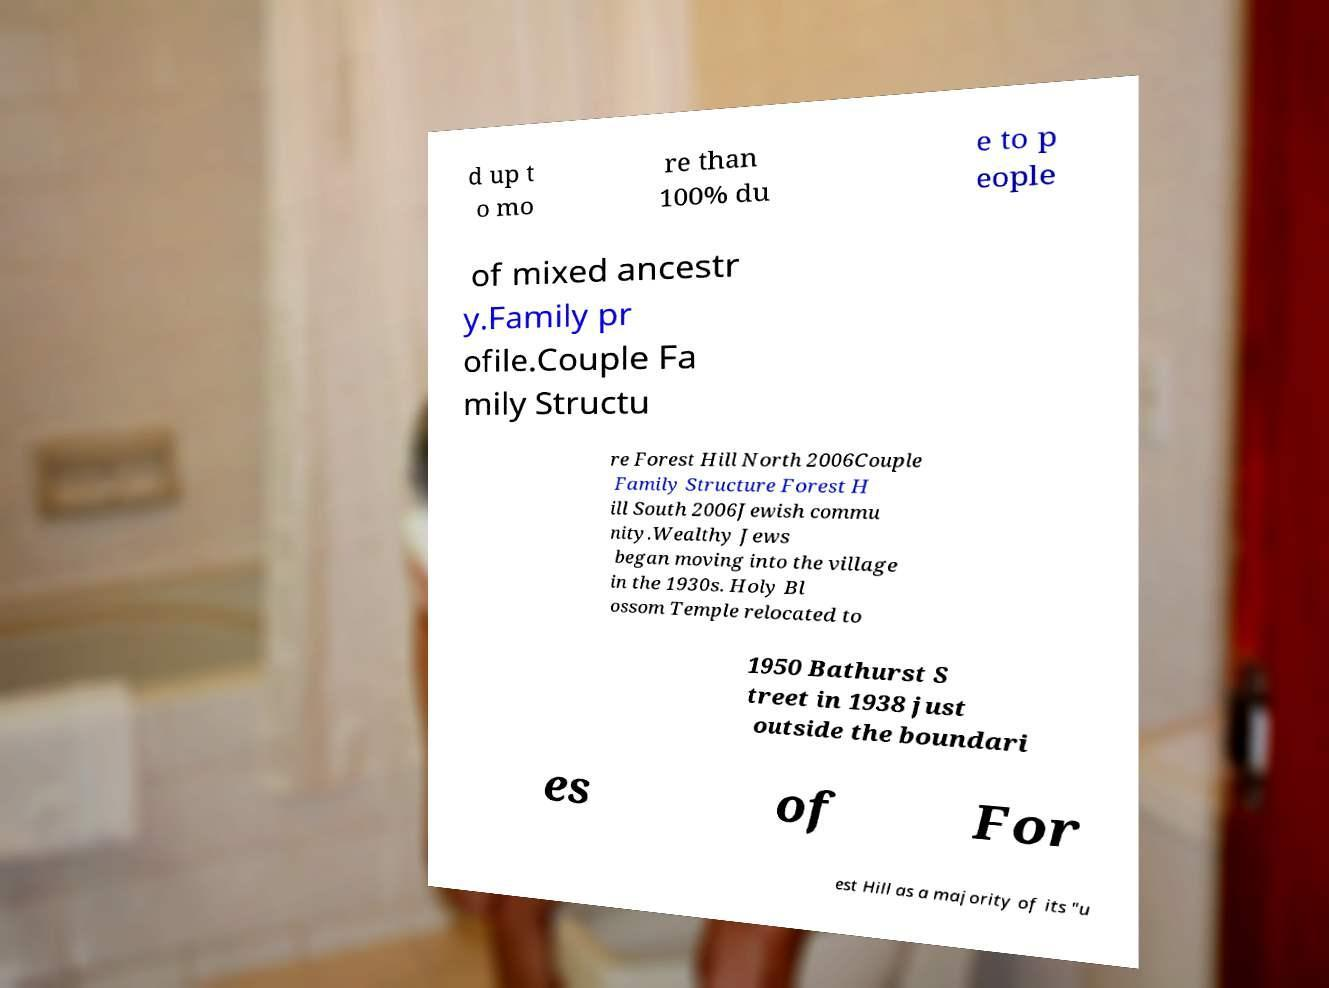Please identify and transcribe the text found in this image. d up t o mo re than 100% du e to p eople of mixed ancestr y.Family pr ofile.Couple Fa mily Structu re Forest Hill North 2006Couple Family Structure Forest H ill South 2006Jewish commu nity.Wealthy Jews began moving into the village in the 1930s. Holy Bl ossom Temple relocated to 1950 Bathurst S treet in 1938 just outside the boundari es of For est Hill as a majority of its "u 